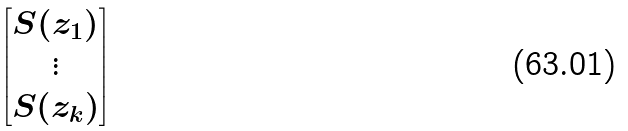Convert formula to latex. <formula><loc_0><loc_0><loc_500><loc_500>\begin{bmatrix} S ( z _ { 1 } ) \\ \vdots \\ S ( z _ { k } ) \end{bmatrix}</formula> 